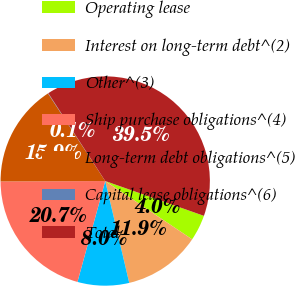Convert chart to OTSL. <chart><loc_0><loc_0><loc_500><loc_500><pie_chart><fcel>Operating lease<fcel>Interest on long-term debt^(2)<fcel>Other^(3)<fcel>Ship purchase obligations^(4)<fcel>Long-term debt obligations^(5)<fcel>Capital lease obligations^(6)<fcel>Total<nl><fcel>4.01%<fcel>11.91%<fcel>7.96%<fcel>20.66%<fcel>15.86%<fcel>0.06%<fcel>39.55%<nl></chart> 